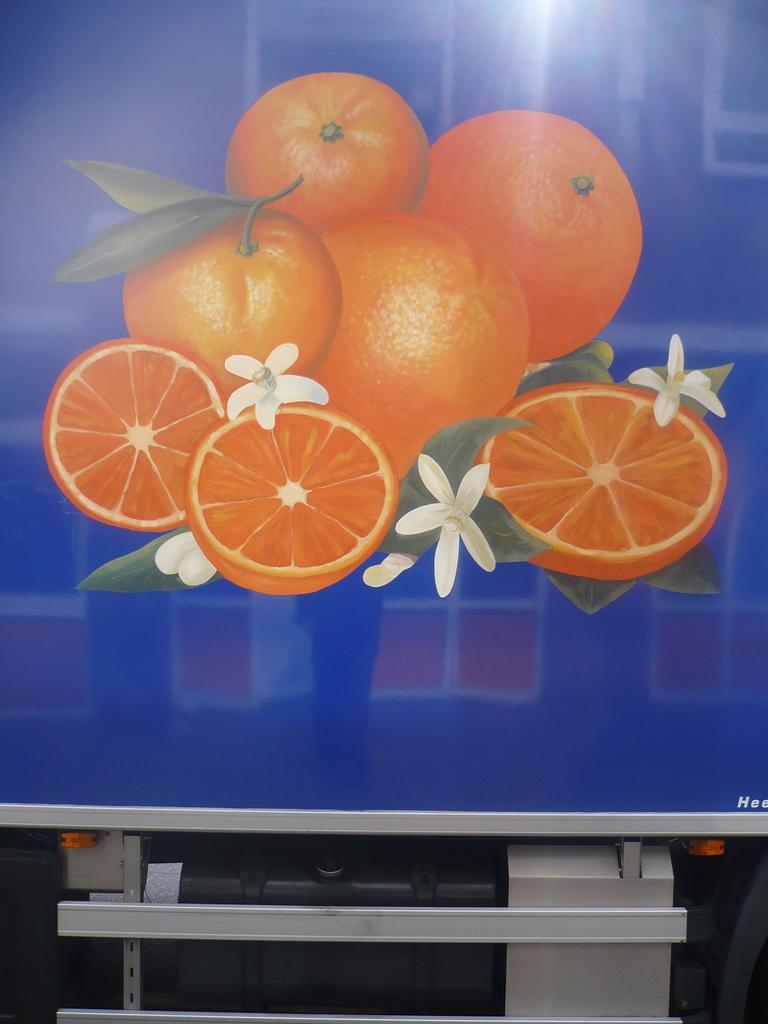What type of fruit can be seen in the image? There are oranges in the image. What other objects or elements are present in the image? There are flowers and a screen visible in the image. What material are the rods made of in the image? The rods in the image are made of metal. Can you describe the setting or location where the image might have been taken? The image may have been taken in a hall. What type of dinosaurs can be seen in the image? There are no dinosaurs present in the image. How does the heartbeat of the flowers in the image compare to the heartbeat of the oranges? There is no information about the heartbeat of the flowers or oranges in the image, as plants do not have hearts. 